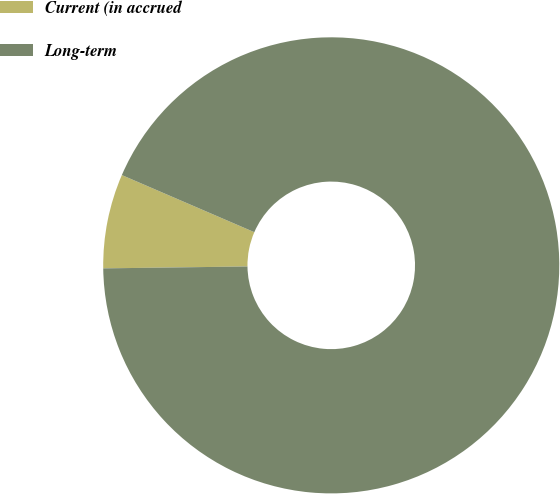Convert chart. <chart><loc_0><loc_0><loc_500><loc_500><pie_chart><fcel>Current (in accrued<fcel>Long-term<nl><fcel>6.69%<fcel>93.31%<nl></chart> 